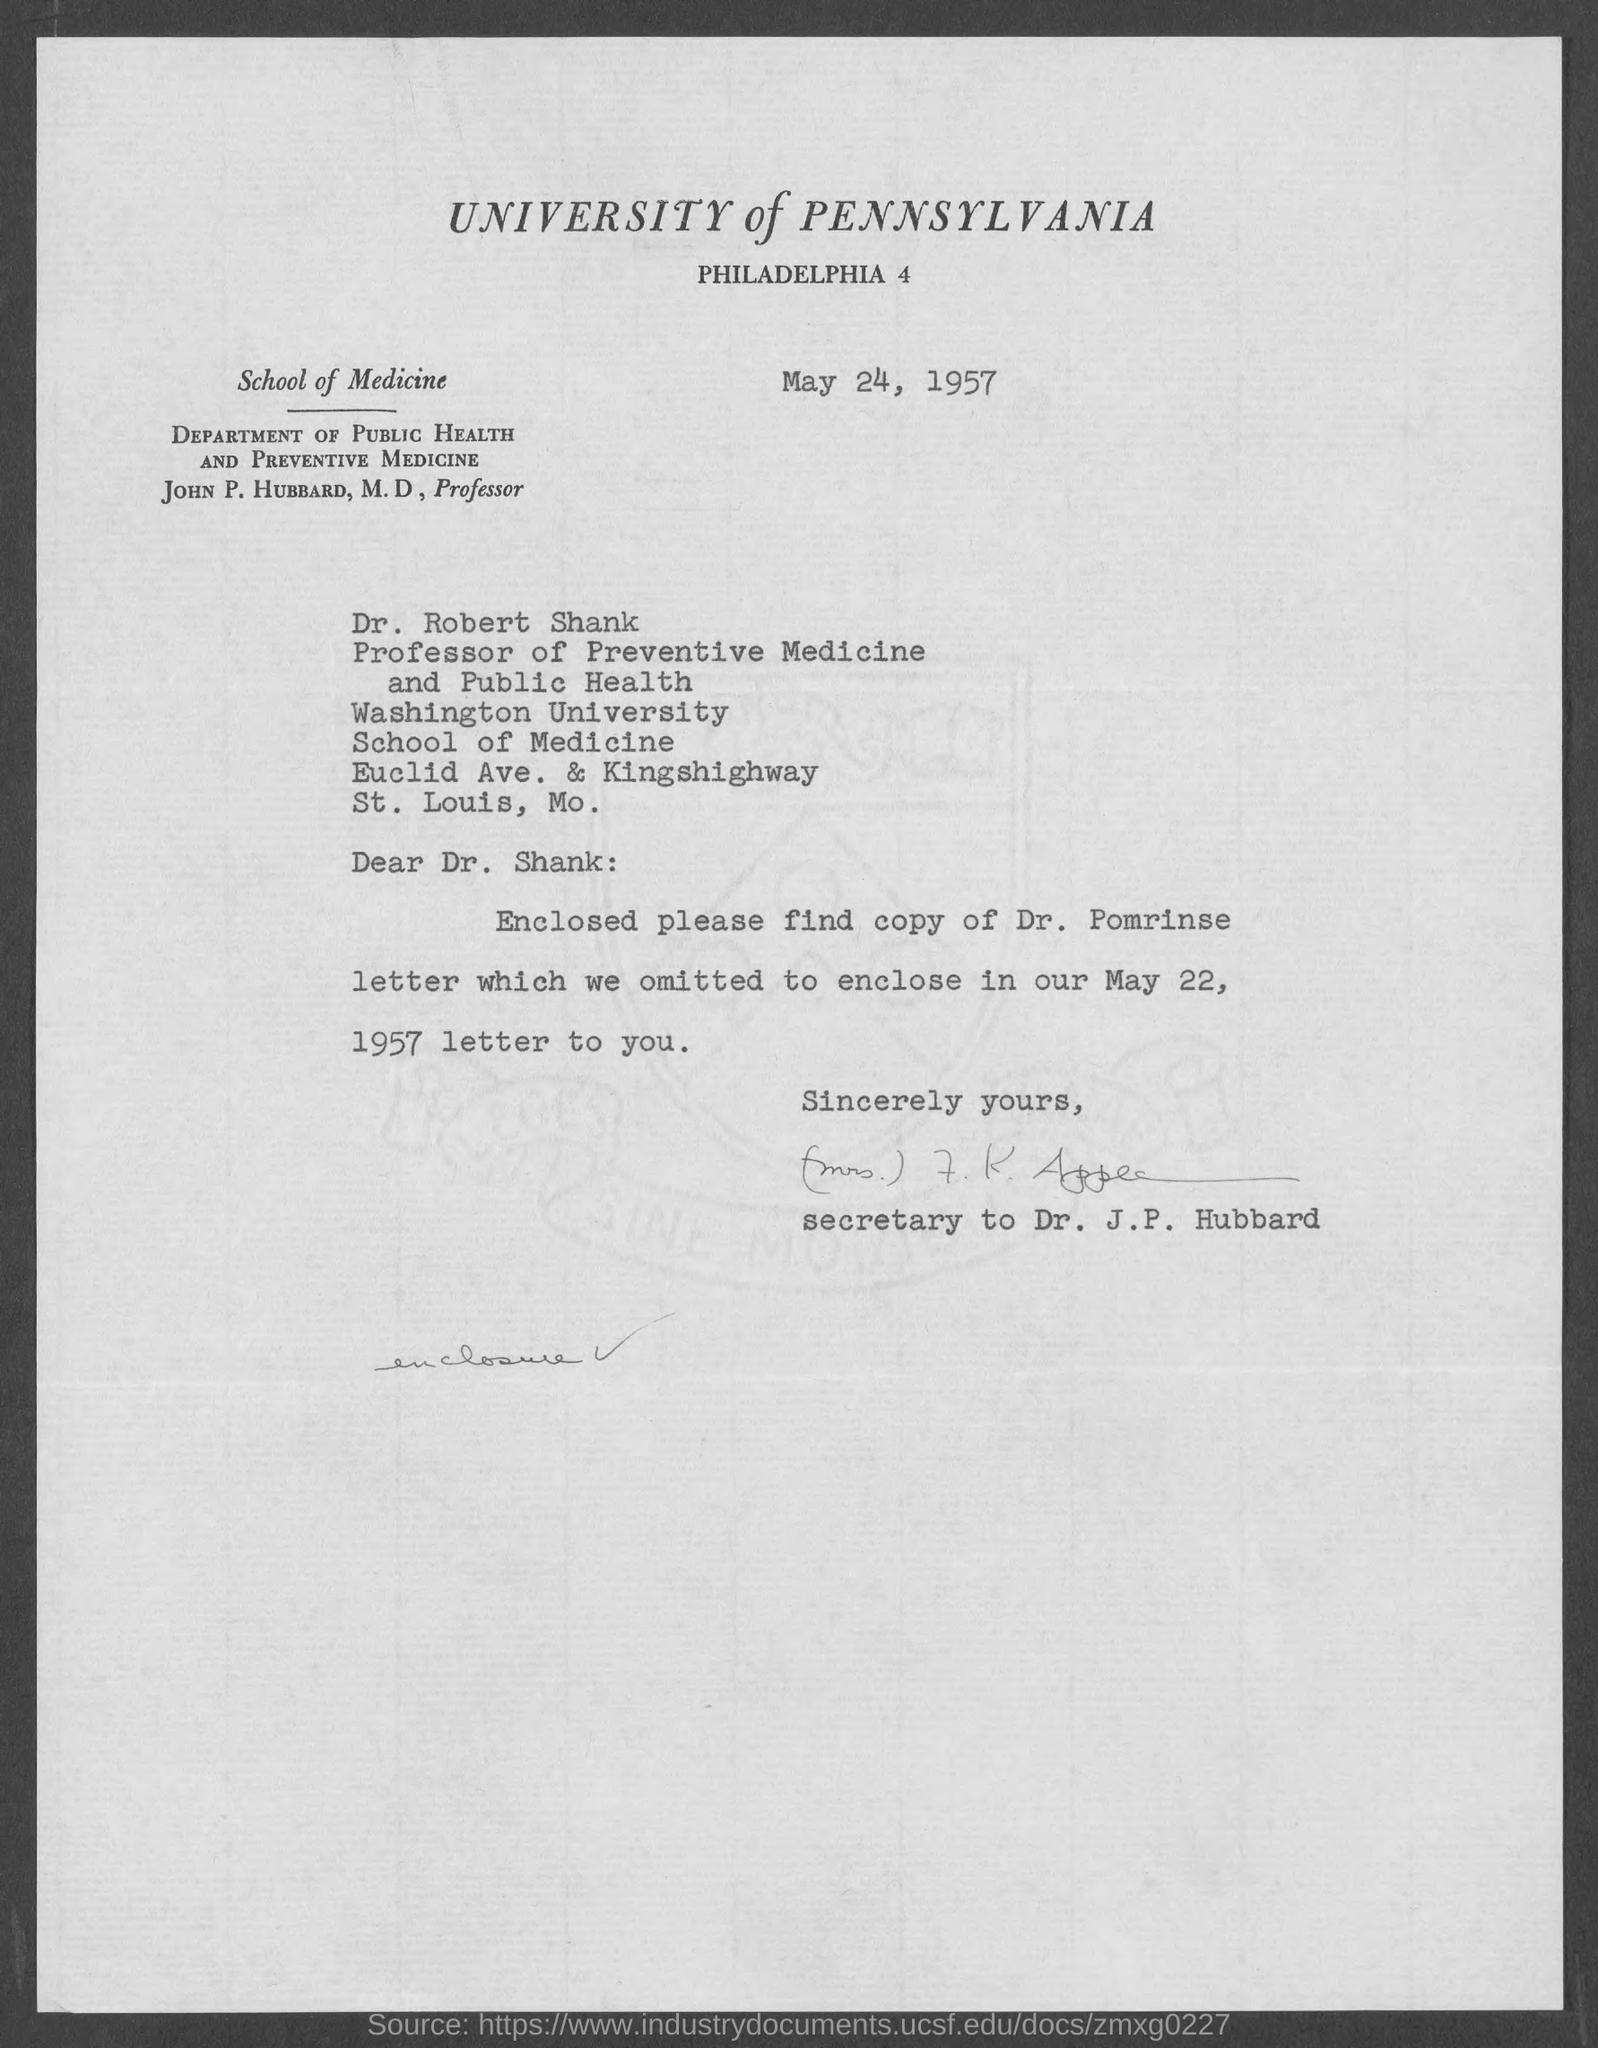What is the date on the letter?
Give a very brief answer. May 24, 1957. To whom is this letter addressed to?
Your response must be concise. Dr. shank. Whose letter's copy is enclosed with this letter?
Your answer should be compact. Dr. pomrinse. 